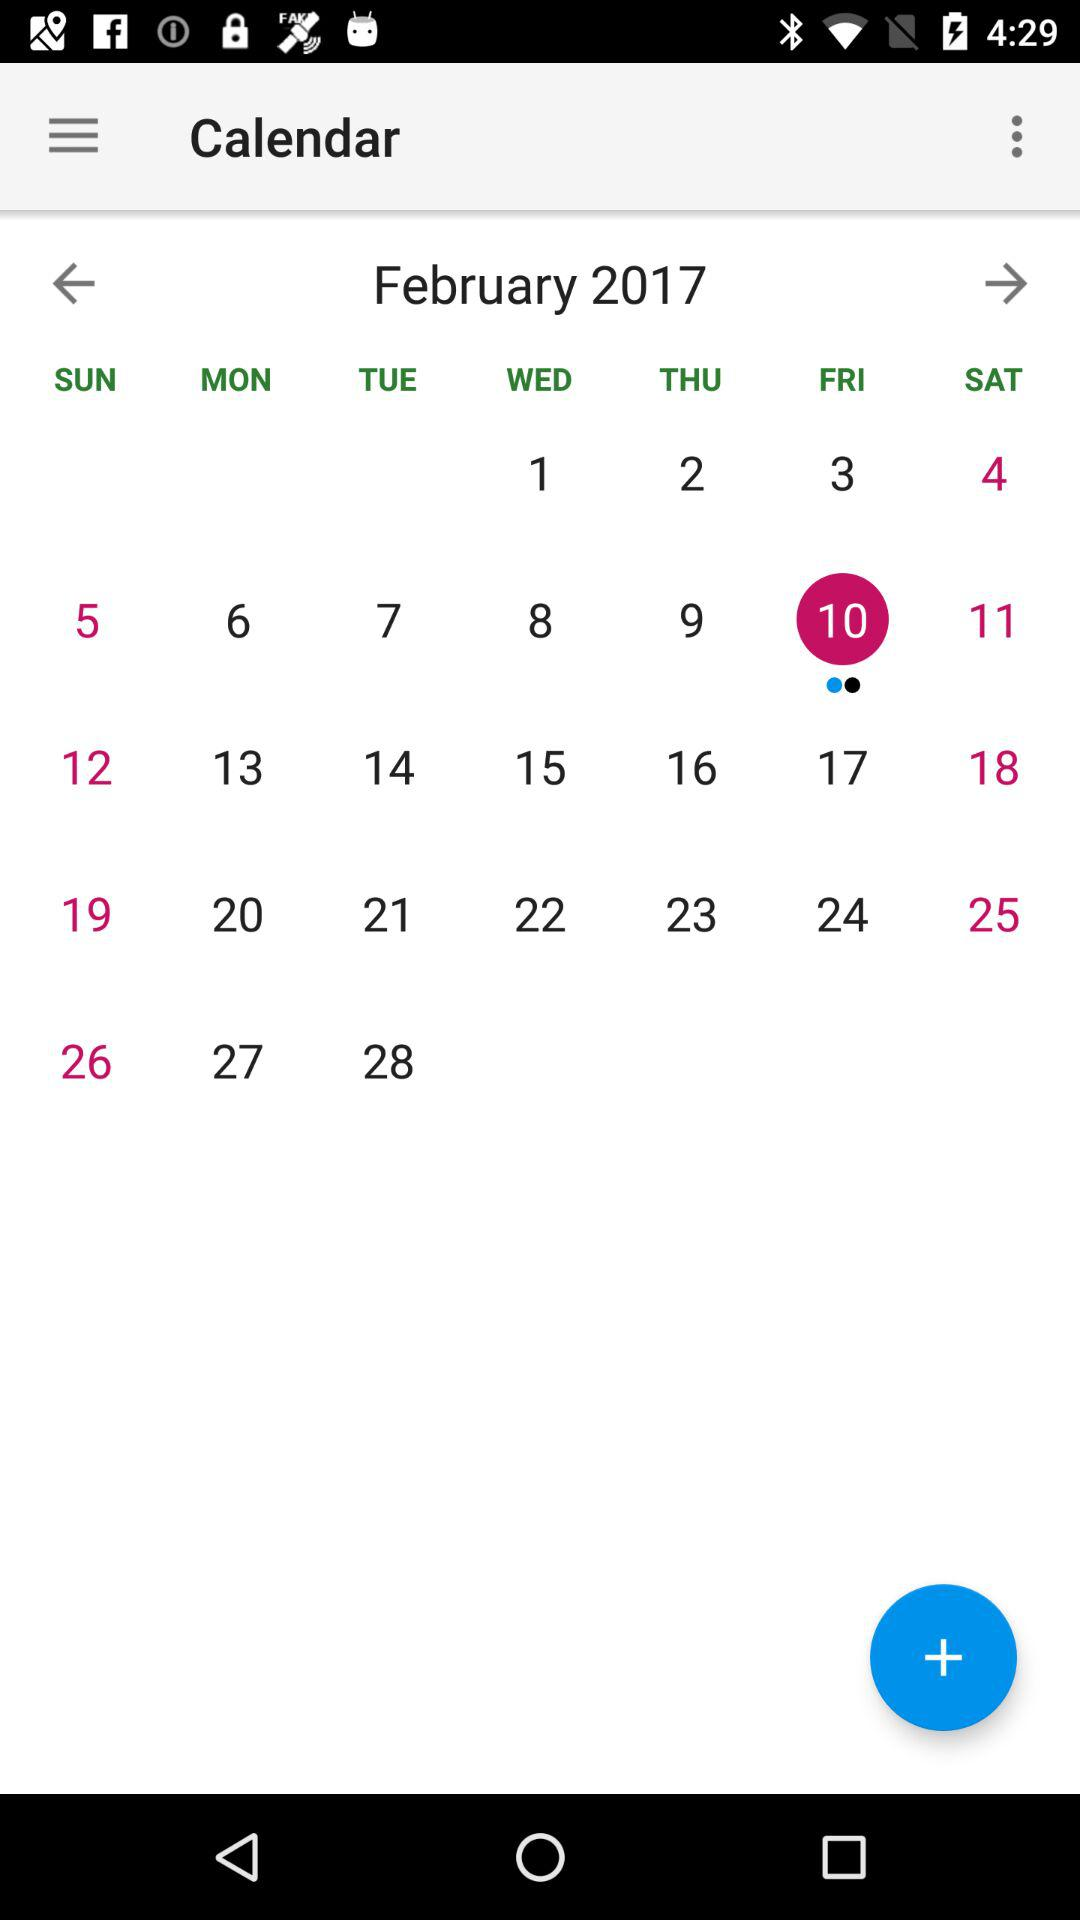What day is February 10? The day is Friday. 